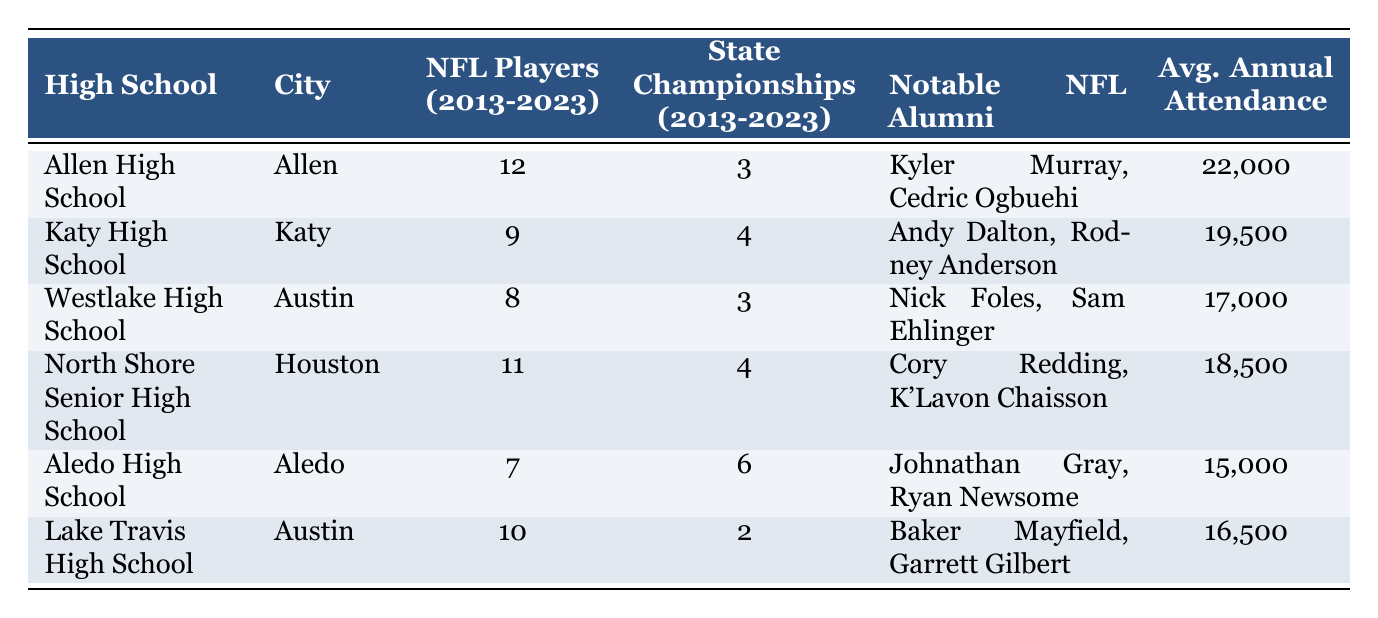What high school produced the most NFL players from 2013 to 2023? Allen High School produced the most NFL players with a total of 12 players.
Answer: 12 Which high school has the highest average annual attendance? Allen High School has the highest average annual attendance at 22,000.
Answer: 22,000 How many state championships did North Shore Senior High School win from 2013 to 2023? North Shore Senior High School won 4 state championships during this period.
Answer: 4 Which two high schools produced the same number of NFL players? Westlake High School and Aledo High School produced 8 and 7 NFL players, respectively. They did not produce the same number. Thus, the answer is none produced the same.
Answer: None What is the total number of NFL players produced by all schools listed? To find the total, we sum the players: 12 + 9 + 8 + 11 + 7 + 10 = 57, so in total, 57 NFL players were produced by all the schools.
Answer: 57 Which high school has more state championships: Katy High School or Lake Travis High School? Katy High School won 4 state championships, while Lake Travis High School won only 2. Therefore, Katy High School has more state championships.
Answer: Katy High School Is it true that Aledo High School has produced more NFL players than Lake Travis High School? Aledo High School produced 7 NFL players while Lake Travis High School produced 10, making the statement false.
Answer: False What is the average number of NFL players produced by the schools listed in the table? The average NFL players can be calculated by summing the total NFL players (57) and dividing by the number of schools (6). Thus, 57 / 6 = 9.5 on average.
Answer: 9.5 How many notable NFL alumni did Allen High School have according to the table? Allen High School has two notable NFL alumni: Kyler Murray and Cedric Ogbuehi.
Answer: 2 Which high school had a notable NFL alumnus that is a quarterback? Both Allen High School (Kyler Murray) and Lake Travis High School (Baker Mayfield) had notable NFL alumni that were quarterbacks.
Answer: Allen and Lake Travis High Schools 